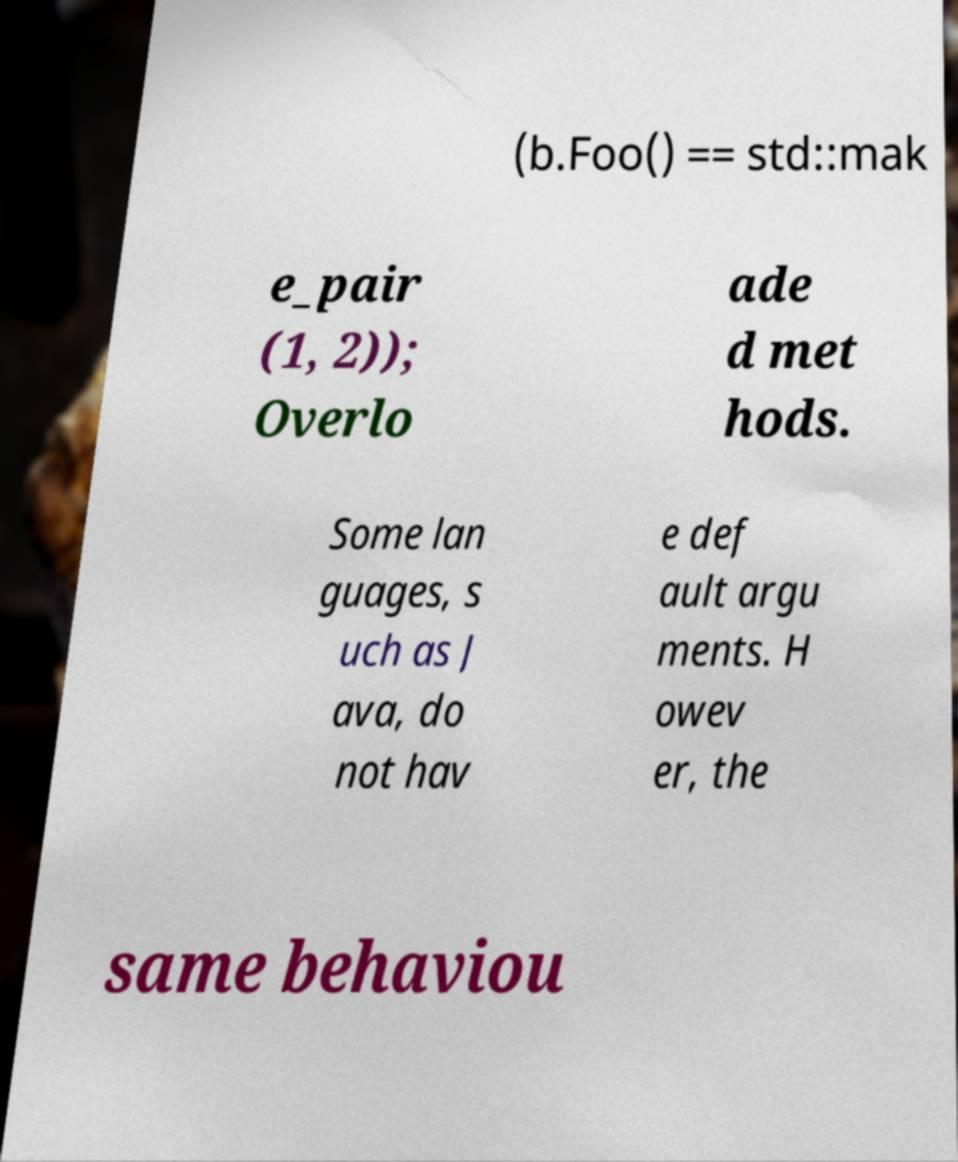Please identify and transcribe the text found in this image. (b.Foo() == std::mak e_pair (1, 2)); Overlo ade d met hods. Some lan guages, s uch as J ava, do not hav e def ault argu ments. H owev er, the same behaviou 